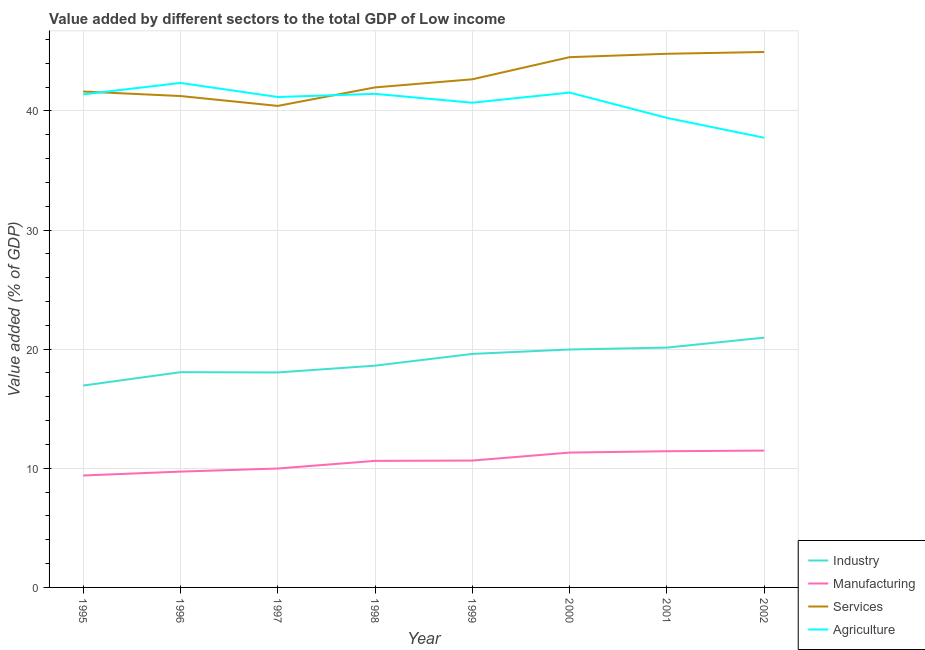Does the line corresponding to value added by services sector intersect with the line corresponding to value added by agricultural sector?
Provide a succinct answer. Yes. What is the value added by industrial sector in 2001?
Give a very brief answer. 20.13. Across all years, what is the maximum value added by agricultural sector?
Make the answer very short. 42.35. Across all years, what is the minimum value added by agricultural sector?
Ensure brevity in your answer.  37.75. In which year was the value added by industrial sector minimum?
Your answer should be compact. 1995. What is the total value added by industrial sector in the graph?
Ensure brevity in your answer.  152.34. What is the difference between the value added by services sector in 1997 and that in 1998?
Give a very brief answer. -1.55. What is the difference between the value added by industrial sector in 2001 and the value added by manufacturing sector in 1999?
Keep it short and to the point. 9.48. What is the average value added by agricultural sector per year?
Offer a very short reply. 40.71. In the year 2001, what is the difference between the value added by manufacturing sector and value added by services sector?
Ensure brevity in your answer.  -33.36. In how many years, is the value added by industrial sector greater than 34 %?
Your response must be concise. 0. What is the ratio of the value added by services sector in 1995 to that in 1996?
Keep it short and to the point. 1.01. What is the difference between the highest and the second highest value added by services sector?
Your answer should be very brief. 0.15. What is the difference between the highest and the lowest value added by manufacturing sector?
Ensure brevity in your answer.  2.09. In how many years, is the value added by services sector greater than the average value added by services sector taken over all years?
Your response must be concise. 3. Is the sum of the value added by agricultural sector in 1999 and 2000 greater than the maximum value added by industrial sector across all years?
Provide a succinct answer. Yes. Is it the case that in every year, the sum of the value added by industrial sector and value added by manufacturing sector is greater than the sum of value added by agricultural sector and value added by services sector?
Your answer should be very brief. No. Is it the case that in every year, the sum of the value added by industrial sector and value added by manufacturing sector is greater than the value added by services sector?
Keep it short and to the point. No. Is the value added by manufacturing sector strictly greater than the value added by services sector over the years?
Give a very brief answer. No. How many lines are there?
Your response must be concise. 4. Does the graph contain any zero values?
Your answer should be compact. No. Where does the legend appear in the graph?
Your response must be concise. Bottom right. How many legend labels are there?
Your answer should be compact. 4. How are the legend labels stacked?
Offer a terse response. Vertical. What is the title of the graph?
Offer a terse response. Value added by different sectors to the total GDP of Low income. Does "Tertiary education" appear as one of the legend labels in the graph?
Offer a terse response. No. What is the label or title of the X-axis?
Your answer should be compact. Year. What is the label or title of the Y-axis?
Provide a short and direct response. Value added (% of GDP). What is the Value added (% of GDP) in Industry in 1995?
Your response must be concise. 16.95. What is the Value added (% of GDP) in Manufacturing in 1995?
Provide a succinct answer. 9.4. What is the Value added (% of GDP) in Services in 1995?
Provide a succinct answer. 41.62. What is the Value added (% of GDP) of Agriculture in 1995?
Make the answer very short. 41.39. What is the Value added (% of GDP) of Industry in 1996?
Offer a terse response. 18.07. What is the Value added (% of GDP) in Manufacturing in 1996?
Your answer should be compact. 9.72. What is the Value added (% of GDP) of Services in 1996?
Offer a very short reply. 41.25. What is the Value added (% of GDP) of Agriculture in 1996?
Your answer should be very brief. 42.35. What is the Value added (% of GDP) of Industry in 1997?
Offer a terse response. 18.04. What is the Value added (% of GDP) of Manufacturing in 1997?
Your answer should be very brief. 9.98. What is the Value added (% of GDP) in Services in 1997?
Your answer should be compact. 40.42. What is the Value added (% of GDP) of Agriculture in 1997?
Offer a very short reply. 41.16. What is the Value added (% of GDP) in Industry in 1998?
Offer a very short reply. 18.61. What is the Value added (% of GDP) in Manufacturing in 1998?
Make the answer very short. 10.62. What is the Value added (% of GDP) of Services in 1998?
Your response must be concise. 41.97. What is the Value added (% of GDP) of Agriculture in 1998?
Your answer should be very brief. 41.43. What is the Value added (% of GDP) of Industry in 1999?
Provide a short and direct response. 19.6. What is the Value added (% of GDP) of Manufacturing in 1999?
Make the answer very short. 10.65. What is the Value added (% of GDP) of Services in 1999?
Ensure brevity in your answer.  42.65. What is the Value added (% of GDP) of Agriculture in 1999?
Ensure brevity in your answer.  40.69. What is the Value added (% of GDP) in Industry in 2000?
Offer a terse response. 19.97. What is the Value added (% of GDP) in Manufacturing in 2000?
Offer a terse response. 11.32. What is the Value added (% of GDP) of Services in 2000?
Give a very brief answer. 44.51. What is the Value added (% of GDP) in Agriculture in 2000?
Offer a terse response. 41.54. What is the Value added (% of GDP) of Industry in 2001?
Your answer should be very brief. 20.13. What is the Value added (% of GDP) in Manufacturing in 2001?
Make the answer very short. 11.43. What is the Value added (% of GDP) in Services in 2001?
Provide a short and direct response. 44.79. What is the Value added (% of GDP) in Agriculture in 2001?
Your answer should be very brief. 39.41. What is the Value added (% of GDP) in Industry in 2002?
Your response must be concise. 20.97. What is the Value added (% of GDP) of Manufacturing in 2002?
Give a very brief answer. 11.49. What is the Value added (% of GDP) of Services in 2002?
Make the answer very short. 44.94. What is the Value added (% of GDP) in Agriculture in 2002?
Give a very brief answer. 37.75. Across all years, what is the maximum Value added (% of GDP) of Industry?
Ensure brevity in your answer.  20.97. Across all years, what is the maximum Value added (% of GDP) in Manufacturing?
Offer a terse response. 11.49. Across all years, what is the maximum Value added (% of GDP) of Services?
Your answer should be compact. 44.94. Across all years, what is the maximum Value added (% of GDP) of Agriculture?
Provide a short and direct response. 42.35. Across all years, what is the minimum Value added (% of GDP) in Industry?
Provide a short and direct response. 16.95. Across all years, what is the minimum Value added (% of GDP) in Manufacturing?
Ensure brevity in your answer.  9.4. Across all years, what is the minimum Value added (% of GDP) of Services?
Make the answer very short. 40.42. Across all years, what is the minimum Value added (% of GDP) in Agriculture?
Provide a short and direct response. 37.75. What is the total Value added (% of GDP) of Industry in the graph?
Offer a very short reply. 152.34. What is the total Value added (% of GDP) of Manufacturing in the graph?
Ensure brevity in your answer.  84.61. What is the total Value added (% of GDP) of Services in the graph?
Offer a very short reply. 342.16. What is the total Value added (% of GDP) of Agriculture in the graph?
Provide a succinct answer. 325.71. What is the difference between the Value added (% of GDP) in Industry in 1995 and that in 1996?
Offer a terse response. -1.12. What is the difference between the Value added (% of GDP) of Manufacturing in 1995 and that in 1996?
Your answer should be very brief. -0.33. What is the difference between the Value added (% of GDP) in Services in 1995 and that in 1996?
Give a very brief answer. 0.38. What is the difference between the Value added (% of GDP) in Agriculture in 1995 and that in 1996?
Offer a very short reply. -0.96. What is the difference between the Value added (% of GDP) in Industry in 1995 and that in 1997?
Keep it short and to the point. -1.1. What is the difference between the Value added (% of GDP) in Manufacturing in 1995 and that in 1997?
Offer a terse response. -0.59. What is the difference between the Value added (% of GDP) in Services in 1995 and that in 1997?
Offer a very short reply. 1.21. What is the difference between the Value added (% of GDP) in Agriculture in 1995 and that in 1997?
Offer a terse response. 0.22. What is the difference between the Value added (% of GDP) of Industry in 1995 and that in 1998?
Your answer should be very brief. -1.67. What is the difference between the Value added (% of GDP) in Manufacturing in 1995 and that in 1998?
Provide a succinct answer. -1.23. What is the difference between the Value added (% of GDP) of Services in 1995 and that in 1998?
Your response must be concise. -0.35. What is the difference between the Value added (% of GDP) of Agriculture in 1995 and that in 1998?
Give a very brief answer. -0.05. What is the difference between the Value added (% of GDP) of Industry in 1995 and that in 1999?
Your answer should be very brief. -2.66. What is the difference between the Value added (% of GDP) in Manufacturing in 1995 and that in 1999?
Offer a very short reply. -1.25. What is the difference between the Value added (% of GDP) of Services in 1995 and that in 1999?
Your answer should be compact. -1.03. What is the difference between the Value added (% of GDP) in Industry in 1995 and that in 2000?
Offer a very short reply. -3.03. What is the difference between the Value added (% of GDP) in Manufacturing in 1995 and that in 2000?
Offer a terse response. -1.92. What is the difference between the Value added (% of GDP) in Services in 1995 and that in 2000?
Provide a short and direct response. -2.88. What is the difference between the Value added (% of GDP) in Agriculture in 1995 and that in 2000?
Offer a very short reply. -0.15. What is the difference between the Value added (% of GDP) of Industry in 1995 and that in 2001?
Your answer should be compact. -3.19. What is the difference between the Value added (% of GDP) in Manufacturing in 1995 and that in 2001?
Ensure brevity in your answer.  -2.04. What is the difference between the Value added (% of GDP) in Services in 1995 and that in 2001?
Ensure brevity in your answer.  -3.17. What is the difference between the Value added (% of GDP) of Agriculture in 1995 and that in 2001?
Offer a terse response. 1.97. What is the difference between the Value added (% of GDP) in Industry in 1995 and that in 2002?
Your answer should be very brief. -4.02. What is the difference between the Value added (% of GDP) of Manufacturing in 1995 and that in 2002?
Provide a succinct answer. -2.09. What is the difference between the Value added (% of GDP) in Services in 1995 and that in 2002?
Ensure brevity in your answer.  -3.32. What is the difference between the Value added (% of GDP) in Agriculture in 1995 and that in 2002?
Provide a succinct answer. 3.64. What is the difference between the Value added (% of GDP) of Industry in 1996 and that in 1997?
Offer a very short reply. 0.02. What is the difference between the Value added (% of GDP) of Manufacturing in 1996 and that in 1997?
Ensure brevity in your answer.  -0.26. What is the difference between the Value added (% of GDP) of Services in 1996 and that in 1997?
Your answer should be compact. 0.83. What is the difference between the Value added (% of GDP) of Agriculture in 1996 and that in 1997?
Offer a terse response. 1.18. What is the difference between the Value added (% of GDP) in Industry in 1996 and that in 1998?
Ensure brevity in your answer.  -0.55. What is the difference between the Value added (% of GDP) of Manufacturing in 1996 and that in 1998?
Make the answer very short. -0.9. What is the difference between the Value added (% of GDP) in Services in 1996 and that in 1998?
Offer a very short reply. -0.72. What is the difference between the Value added (% of GDP) of Agriculture in 1996 and that in 1998?
Offer a terse response. 0.92. What is the difference between the Value added (% of GDP) of Industry in 1996 and that in 1999?
Give a very brief answer. -1.53. What is the difference between the Value added (% of GDP) in Manufacturing in 1996 and that in 1999?
Keep it short and to the point. -0.93. What is the difference between the Value added (% of GDP) of Services in 1996 and that in 1999?
Your response must be concise. -1.41. What is the difference between the Value added (% of GDP) of Agriculture in 1996 and that in 1999?
Ensure brevity in your answer.  1.66. What is the difference between the Value added (% of GDP) of Industry in 1996 and that in 2000?
Your answer should be compact. -1.9. What is the difference between the Value added (% of GDP) in Manufacturing in 1996 and that in 2000?
Give a very brief answer. -1.6. What is the difference between the Value added (% of GDP) of Services in 1996 and that in 2000?
Offer a very short reply. -3.26. What is the difference between the Value added (% of GDP) in Agriculture in 1996 and that in 2000?
Keep it short and to the point. 0.81. What is the difference between the Value added (% of GDP) in Industry in 1996 and that in 2001?
Provide a succinct answer. -2.06. What is the difference between the Value added (% of GDP) in Manufacturing in 1996 and that in 2001?
Provide a short and direct response. -1.71. What is the difference between the Value added (% of GDP) in Services in 1996 and that in 2001?
Give a very brief answer. -3.55. What is the difference between the Value added (% of GDP) in Agriculture in 1996 and that in 2001?
Keep it short and to the point. 2.93. What is the difference between the Value added (% of GDP) of Industry in 1996 and that in 2002?
Your answer should be compact. -2.9. What is the difference between the Value added (% of GDP) of Manufacturing in 1996 and that in 2002?
Your response must be concise. -1.76. What is the difference between the Value added (% of GDP) in Services in 1996 and that in 2002?
Provide a succinct answer. -3.7. What is the difference between the Value added (% of GDP) in Agriculture in 1996 and that in 2002?
Provide a short and direct response. 4.6. What is the difference between the Value added (% of GDP) in Industry in 1997 and that in 1998?
Give a very brief answer. -0.57. What is the difference between the Value added (% of GDP) of Manufacturing in 1997 and that in 1998?
Keep it short and to the point. -0.64. What is the difference between the Value added (% of GDP) in Services in 1997 and that in 1998?
Your response must be concise. -1.55. What is the difference between the Value added (% of GDP) in Agriculture in 1997 and that in 1998?
Your answer should be very brief. -0.27. What is the difference between the Value added (% of GDP) in Industry in 1997 and that in 1999?
Your response must be concise. -1.56. What is the difference between the Value added (% of GDP) in Manufacturing in 1997 and that in 1999?
Ensure brevity in your answer.  -0.67. What is the difference between the Value added (% of GDP) of Services in 1997 and that in 1999?
Your answer should be very brief. -2.23. What is the difference between the Value added (% of GDP) in Agriculture in 1997 and that in 1999?
Your answer should be very brief. 0.48. What is the difference between the Value added (% of GDP) of Industry in 1997 and that in 2000?
Offer a very short reply. -1.93. What is the difference between the Value added (% of GDP) of Manufacturing in 1997 and that in 2000?
Offer a terse response. -1.34. What is the difference between the Value added (% of GDP) in Services in 1997 and that in 2000?
Offer a very short reply. -4.09. What is the difference between the Value added (% of GDP) of Agriculture in 1997 and that in 2000?
Give a very brief answer. -0.37. What is the difference between the Value added (% of GDP) in Industry in 1997 and that in 2001?
Give a very brief answer. -2.09. What is the difference between the Value added (% of GDP) of Manufacturing in 1997 and that in 2001?
Your response must be concise. -1.45. What is the difference between the Value added (% of GDP) in Services in 1997 and that in 2001?
Your answer should be very brief. -4.38. What is the difference between the Value added (% of GDP) of Agriculture in 1997 and that in 2001?
Offer a terse response. 1.75. What is the difference between the Value added (% of GDP) in Industry in 1997 and that in 2002?
Provide a succinct answer. -2.92. What is the difference between the Value added (% of GDP) of Manufacturing in 1997 and that in 2002?
Offer a very short reply. -1.51. What is the difference between the Value added (% of GDP) in Services in 1997 and that in 2002?
Make the answer very short. -4.53. What is the difference between the Value added (% of GDP) of Agriculture in 1997 and that in 2002?
Ensure brevity in your answer.  3.42. What is the difference between the Value added (% of GDP) in Industry in 1998 and that in 1999?
Keep it short and to the point. -0.99. What is the difference between the Value added (% of GDP) in Manufacturing in 1998 and that in 1999?
Offer a terse response. -0.02. What is the difference between the Value added (% of GDP) in Services in 1998 and that in 1999?
Give a very brief answer. -0.68. What is the difference between the Value added (% of GDP) of Agriculture in 1998 and that in 1999?
Make the answer very short. 0.75. What is the difference between the Value added (% of GDP) of Industry in 1998 and that in 2000?
Give a very brief answer. -1.36. What is the difference between the Value added (% of GDP) of Manufacturing in 1998 and that in 2000?
Ensure brevity in your answer.  -0.7. What is the difference between the Value added (% of GDP) of Services in 1998 and that in 2000?
Offer a very short reply. -2.54. What is the difference between the Value added (% of GDP) of Agriculture in 1998 and that in 2000?
Give a very brief answer. -0.11. What is the difference between the Value added (% of GDP) in Industry in 1998 and that in 2001?
Give a very brief answer. -1.52. What is the difference between the Value added (% of GDP) in Manufacturing in 1998 and that in 2001?
Keep it short and to the point. -0.81. What is the difference between the Value added (% of GDP) in Services in 1998 and that in 2001?
Keep it short and to the point. -2.82. What is the difference between the Value added (% of GDP) of Agriculture in 1998 and that in 2001?
Your answer should be compact. 2.02. What is the difference between the Value added (% of GDP) in Industry in 1998 and that in 2002?
Offer a terse response. -2.35. What is the difference between the Value added (% of GDP) in Manufacturing in 1998 and that in 2002?
Your response must be concise. -0.86. What is the difference between the Value added (% of GDP) of Services in 1998 and that in 2002?
Ensure brevity in your answer.  -2.97. What is the difference between the Value added (% of GDP) in Agriculture in 1998 and that in 2002?
Your response must be concise. 3.68. What is the difference between the Value added (% of GDP) of Industry in 1999 and that in 2000?
Keep it short and to the point. -0.37. What is the difference between the Value added (% of GDP) in Manufacturing in 1999 and that in 2000?
Offer a very short reply. -0.67. What is the difference between the Value added (% of GDP) in Services in 1999 and that in 2000?
Ensure brevity in your answer.  -1.86. What is the difference between the Value added (% of GDP) of Agriculture in 1999 and that in 2000?
Your answer should be compact. -0.85. What is the difference between the Value added (% of GDP) of Industry in 1999 and that in 2001?
Provide a short and direct response. -0.53. What is the difference between the Value added (% of GDP) in Manufacturing in 1999 and that in 2001?
Give a very brief answer. -0.78. What is the difference between the Value added (% of GDP) of Services in 1999 and that in 2001?
Provide a short and direct response. -2.14. What is the difference between the Value added (% of GDP) of Agriculture in 1999 and that in 2001?
Keep it short and to the point. 1.27. What is the difference between the Value added (% of GDP) in Industry in 1999 and that in 2002?
Your answer should be very brief. -1.36. What is the difference between the Value added (% of GDP) in Manufacturing in 1999 and that in 2002?
Offer a very short reply. -0.84. What is the difference between the Value added (% of GDP) of Services in 1999 and that in 2002?
Give a very brief answer. -2.29. What is the difference between the Value added (% of GDP) of Agriculture in 1999 and that in 2002?
Your answer should be very brief. 2.94. What is the difference between the Value added (% of GDP) of Industry in 2000 and that in 2001?
Offer a very short reply. -0.16. What is the difference between the Value added (% of GDP) in Manufacturing in 2000 and that in 2001?
Provide a short and direct response. -0.11. What is the difference between the Value added (% of GDP) of Services in 2000 and that in 2001?
Your answer should be compact. -0.28. What is the difference between the Value added (% of GDP) of Agriculture in 2000 and that in 2001?
Your answer should be compact. 2.12. What is the difference between the Value added (% of GDP) in Industry in 2000 and that in 2002?
Provide a short and direct response. -0.99. What is the difference between the Value added (% of GDP) in Services in 2000 and that in 2002?
Ensure brevity in your answer.  -0.43. What is the difference between the Value added (% of GDP) in Agriculture in 2000 and that in 2002?
Make the answer very short. 3.79. What is the difference between the Value added (% of GDP) of Industry in 2001 and that in 2002?
Your response must be concise. -0.83. What is the difference between the Value added (% of GDP) in Manufacturing in 2001 and that in 2002?
Make the answer very short. -0.05. What is the difference between the Value added (% of GDP) of Services in 2001 and that in 2002?
Your answer should be very brief. -0.15. What is the difference between the Value added (% of GDP) in Agriculture in 2001 and that in 2002?
Provide a short and direct response. 1.67. What is the difference between the Value added (% of GDP) in Industry in 1995 and the Value added (% of GDP) in Manufacturing in 1996?
Ensure brevity in your answer.  7.22. What is the difference between the Value added (% of GDP) in Industry in 1995 and the Value added (% of GDP) in Services in 1996?
Your answer should be very brief. -24.3. What is the difference between the Value added (% of GDP) of Industry in 1995 and the Value added (% of GDP) of Agriculture in 1996?
Offer a very short reply. -25.4. What is the difference between the Value added (% of GDP) of Manufacturing in 1995 and the Value added (% of GDP) of Services in 1996?
Your answer should be compact. -31.85. What is the difference between the Value added (% of GDP) in Manufacturing in 1995 and the Value added (% of GDP) in Agriculture in 1996?
Keep it short and to the point. -32.95. What is the difference between the Value added (% of GDP) in Services in 1995 and the Value added (% of GDP) in Agriculture in 1996?
Offer a terse response. -0.72. What is the difference between the Value added (% of GDP) in Industry in 1995 and the Value added (% of GDP) in Manufacturing in 1997?
Make the answer very short. 6.96. What is the difference between the Value added (% of GDP) in Industry in 1995 and the Value added (% of GDP) in Services in 1997?
Provide a succinct answer. -23.47. What is the difference between the Value added (% of GDP) of Industry in 1995 and the Value added (% of GDP) of Agriculture in 1997?
Ensure brevity in your answer.  -24.22. What is the difference between the Value added (% of GDP) of Manufacturing in 1995 and the Value added (% of GDP) of Services in 1997?
Provide a short and direct response. -31.02. What is the difference between the Value added (% of GDP) of Manufacturing in 1995 and the Value added (% of GDP) of Agriculture in 1997?
Offer a terse response. -31.77. What is the difference between the Value added (% of GDP) in Services in 1995 and the Value added (% of GDP) in Agriculture in 1997?
Offer a terse response. 0.46. What is the difference between the Value added (% of GDP) of Industry in 1995 and the Value added (% of GDP) of Manufacturing in 1998?
Your answer should be compact. 6.32. What is the difference between the Value added (% of GDP) in Industry in 1995 and the Value added (% of GDP) in Services in 1998?
Offer a terse response. -25.03. What is the difference between the Value added (% of GDP) of Industry in 1995 and the Value added (% of GDP) of Agriculture in 1998?
Offer a very short reply. -24.49. What is the difference between the Value added (% of GDP) in Manufacturing in 1995 and the Value added (% of GDP) in Services in 1998?
Keep it short and to the point. -32.58. What is the difference between the Value added (% of GDP) of Manufacturing in 1995 and the Value added (% of GDP) of Agriculture in 1998?
Make the answer very short. -32.04. What is the difference between the Value added (% of GDP) in Services in 1995 and the Value added (% of GDP) in Agriculture in 1998?
Your response must be concise. 0.19. What is the difference between the Value added (% of GDP) of Industry in 1995 and the Value added (% of GDP) of Manufacturing in 1999?
Your response must be concise. 6.3. What is the difference between the Value added (% of GDP) of Industry in 1995 and the Value added (% of GDP) of Services in 1999?
Give a very brief answer. -25.71. What is the difference between the Value added (% of GDP) of Industry in 1995 and the Value added (% of GDP) of Agriculture in 1999?
Your response must be concise. -23.74. What is the difference between the Value added (% of GDP) of Manufacturing in 1995 and the Value added (% of GDP) of Services in 1999?
Your response must be concise. -33.26. What is the difference between the Value added (% of GDP) of Manufacturing in 1995 and the Value added (% of GDP) of Agriculture in 1999?
Offer a terse response. -31.29. What is the difference between the Value added (% of GDP) in Services in 1995 and the Value added (% of GDP) in Agriculture in 1999?
Give a very brief answer. 0.94. What is the difference between the Value added (% of GDP) of Industry in 1995 and the Value added (% of GDP) of Manufacturing in 2000?
Provide a succinct answer. 5.63. What is the difference between the Value added (% of GDP) in Industry in 1995 and the Value added (% of GDP) in Services in 2000?
Keep it short and to the point. -27.56. What is the difference between the Value added (% of GDP) of Industry in 1995 and the Value added (% of GDP) of Agriculture in 2000?
Offer a terse response. -24.59. What is the difference between the Value added (% of GDP) in Manufacturing in 1995 and the Value added (% of GDP) in Services in 2000?
Your answer should be very brief. -35.11. What is the difference between the Value added (% of GDP) of Manufacturing in 1995 and the Value added (% of GDP) of Agriculture in 2000?
Provide a succinct answer. -32.14. What is the difference between the Value added (% of GDP) of Services in 1995 and the Value added (% of GDP) of Agriculture in 2000?
Give a very brief answer. 0.09. What is the difference between the Value added (% of GDP) in Industry in 1995 and the Value added (% of GDP) in Manufacturing in 2001?
Ensure brevity in your answer.  5.51. What is the difference between the Value added (% of GDP) in Industry in 1995 and the Value added (% of GDP) in Services in 2001?
Your response must be concise. -27.85. What is the difference between the Value added (% of GDP) of Industry in 1995 and the Value added (% of GDP) of Agriculture in 2001?
Ensure brevity in your answer.  -22.47. What is the difference between the Value added (% of GDP) in Manufacturing in 1995 and the Value added (% of GDP) in Services in 2001?
Provide a succinct answer. -35.4. What is the difference between the Value added (% of GDP) of Manufacturing in 1995 and the Value added (% of GDP) of Agriculture in 2001?
Your answer should be very brief. -30.02. What is the difference between the Value added (% of GDP) of Services in 1995 and the Value added (% of GDP) of Agriculture in 2001?
Provide a short and direct response. 2.21. What is the difference between the Value added (% of GDP) in Industry in 1995 and the Value added (% of GDP) in Manufacturing in 2002?
Give a very brief answer. 5.46. What is the difference between the Value added (% of GDP) in Industry in 1995 and the Value added (% of GDP) in Services in 2002?
Keep it short and to the point. -28. What is the difference between the Value added (% of GDP) in Industry in 1995 and the Value added (% of GDP) in Agriculture in 2002?
Offer a very short reply. -20.8. What is the difference between the Value added (% of GDP) of Manufacturing in 1995 and the Value added (% of GDP) of Services in 2002?
Ensure brevity in your answer.  -35.55. What is the difference between the Value added (% of GDP) in Manufacturing in 1995 and the Value added (% of GDP) in Agriculture in 2002?
Give a very brief answer. -28.35. What is the difference between the Value added (% of GDP) in Services in 1995 and the Value added (% of GDP) in Agriculture in 2002?
Provide a short and direct response. 3.88. What is the difference between the Value added (% of GDP) in Industry in 1996 and the Value added (% of GDP) in Manufacturing in 1997?
Make the answer very short. 8.09. What is the difference between the Value added (% of GDP) in Industry in 1996 and the Value added (% of GDP) in Services in 1997?
Provide a short and direct response. -22.35. What is the difference between the Value added (% of GDP) in Industry in 1996 and the Value added (% of GDP) in Agriculture in 1997?
Offer a terse response. -23.1. What is the difference between the Value added (% of GDP) of Manufacturing in 1996 and the Value added (% of GDP) of Services in 1997?
Offer a very short reply. -30.7. What is the difference between the Value added (% of GDP) of Manufacturing in 1996 and the Value added (% of GDP) of Agriculture in 1997?
Offer a terse response. -31.44. What is the difference between the Value added (% of GDP) of Services in 1996 and the Value added (% of GDP) of Agriculture in 1997?
Your answer should be very brief. 0.08. What is the difference between the Value added (% of GDP) of Industry in 1996 and the Value added (% of GDP) of Manufacturing in 1998?
Offer a terse response. 7.44. What is the difference between the Value added (% of GDP) in Industry in 1996 and the Value added (% of GDP) in Services in 1998?
Your answer should be compact. -23.9. What is the difference between the Value added (% of GDP) in Industry in 1996 and the Value added (% of GDP) in Agriculture in 1998?
Provide a short and direct response. -23.36. What is the difference between the Value added (% of GDP) of Manufacturing in 1996 and the Value added (% of GDP) of Services in 1998?
Your answer should be very brief. -32.25. What is the difference between the Value added (% of GDP) in Manufacturing in 1996 and the Value added (% of GDP) in Agriculture in 1998?
Give a very brief answer. -31.71. What is the difference between the Value added (% of GDP) in Services in 1996 and the Value added (% of GDP) in Agriculture in 1998?
Your response must be concise. -0.18. What is the difference between the Value added (% of GDP) of Industry in 1996 and the Value added (% of GDP) of Manufacturing in 1999?
Offer a very short reply. 7.42. What is the difference between the Value added (% of GDP) in Industry in 1996 and the Value added (% of GDP) in Services in 1999?
Offer a terse response. -24.58. What is the difference between the Value added (% of GDP) in Industry in 1996 and the Value added (% of GDP) in Agriculture in 1999?
Keep it short and to the point. -22.62. What is the difference between the Value added (% of GDP) in Manufacturing in 1996 and the Value added (% of GDP) in Services in 1999?
Ensure brevity in your answer.  -32.93. What is the difference between the Value added (% of GDP) in Manufacturing in 1996 and the Value added (% of GDP) in Agriculture in 1999?
Your answer should be very brief. -30.96. What is the difference between the Value added (% of GDP) in Services in 1996 and the Value added (% of GDP) in Agriculture in 1999?
Your response must be concise. 0.56. What is the difference between the Value added (% of GDP) of Industry in 1996 and the Value added (% of GDP) of Manufacturing in 2000?
Your answer should be compact. 6.75. What is the difference between the Value added (% of GDP) in Industry in 1996 and the Value added (% of GDP) in Services in 2000?
Provide a short and direct response. -26.44. What is the difference between the Value added (% of GDP) of Industry in 1996 and the Value added (% of GDP) of Agriculture in 2000?
Provide a short and direct response. -23.47. What is the difference between the Value added (% of GDP) in Manufacturing in 1996 and the Value added (% of GDP) in Services in 2000?
Keep it short and to the point. -34.79. What is the difference between the Value added (% of GDP) in Manufacturing in 1996 and the Value added (% of GDP) in Agriculture in 2000?
Keep it short and to the point. -31.82. What is the difference between the Value added (% of GDP) in Services in 1996 and the Value added (% of GDP) in Agriculture in 2000?
Your answer should be very brief. -0.29. What is the difference between the Value added (% of GDP) in Industry in 1996 and the Value added (% of GDP) in Manufacturing in 2001?
Your answer should be very brief. 6.64. What is the difference between the Value added (% of GDP) of Industry in 1996 and the Value added (% of GDP) of Services in 2001?
Offer a very short reply. -26.73. What is the difference between the Value added (% of GDP) in Industry in 1996 and the Value added (% of GDP) in Agriculture in 2001?
Your answer should be very brief. -21.35. What is the difference between the Value added (% of GDP) in Manufacturing in 1996 and the Value added (% of GDP) in Services in 2001?
Provide a short and direct response. -35.07. What is the difference between the Value added (% of GDP) in Manufacturing in 1996 and the Value added (% of GDP) in Agriculture in 2001?
Provide a succinct answer. -29.69. What is the difference between the Value added (% of GDP) of Services in 1996 and the Value added (% of GDP) of Agriculture in 2001?
Your answer should be compact. 1.83. What is the difference between the Value added (% of GDP) of Industry in 1996 and the Value added (% of GDP) of Manufacturing in 2002?
Offer a terse response. 6.58. What is the difference between the Value added (% of GDP) of Industry in 1996 and the Value added (% of GDP) of Services in 2002?
Make the answer very short. -26.87. What is the difference between the Value added (% of GDP) in Industry in 1996 and the Value added (% of GDP) in Agriculture in 2002?
Ensure brevity in your answer.  -19.68. What is the difference between the Value added (% of GDP) of Manufacturing in 1996 and the Value added (% of GDP) of Services in 2002?
Ensure brevity in your answer.  -35.22. What is the difference between the Value added (% of GDP) of Manufacturing in 1996 and the Value added (% of GDP) of Agriculture in 2002?
Offer a very short reply. -28.03. What is the difference between the Value added (% of GDP) in Services in 1996 and the Value added (% of GDP) in Agriculture in 2002?
Provide a succinct answer. 3.5. What is the difference between the Value added (% of GDP) in Industry in 1997 and the Value added (% of GDP) in Manufacturing in 1998?
Provide a succinct answer. 7.42. What is the difference between the Value added (% of GDP) of Industry in 1997 and the Value added (% of GDP) of Services in 1998?
Ensure brevity in your answer.  -23.93. What is the difference between the Value added (% of GDP) in Industry in 1997 and the Value added (% of GDP) in Agriculture in 1998?
Your answer should be very brief. -23.39. What is the difference between the Value added (% of GDP) of Manufacturing in 1997 and the Value added (% of GDP) of Services in 1998?
Keep it short and to the point. -31.99. What is the difference between the Value added (% of GDP) of Manufacturing in 1997 and the Value added (% of GDP) of Agriculture in 1998?
Offer a very short reply. -31.45. What is the difference between the Value added (% of GDP) of Services in 1997 and the Value added (% of GDP) of Agriculture in 1998?
Offer a very short reply. -1.01. What is the difference between the Value added (% of GDP) in Industry in 1997 and the Value added (% of GDP) in Manufacturing in 1999?
Offer a very short reply. 7.4. What is the difference between the Value added (% of GDP) of Industry in 1997 and the Value added (% of GDP) of Services in 1999?
Offer a very short reply. -24.61. What is the difference between the Value added (% of GDP) in Industry in 1997 and the Value added (% of GDP) in Agriculture in 1999?
Provide a succinct answer. -22.64. What is the difference between the Value added (% of GDP) of Manufacturing in 1997 and the Value added (% of GDP) of Services in 1999?
Keep it short and to the point. -32.67. What is the difference between the Value added (% of GDP) of Manufacturing in 1997 and the Value added (% of GDP) of Agriculture in 1999?
Make the answer very short. -30.7. What is the difference between the Value added (% of GDP) of Services in 1997 and the Value added (% of GDP) of Agriculture in 1999?
Provide a succinct answer. -0.27. What is the difference between the Value added (% of GDP) in Industry in 1997 and the Value added (% of GDP) in Manufacturing in 2000?
Offer a very short reply. 6.72. What is the difference between the Value added (% of GDP) of Industry in 1997 and the Value added (% of GDP) of Services in 2000?
Make the answer very short. -26.46. What is the difference between the Value added (% of GDP) of Industry in 1997 and the Value added (% of GDP) of Agriculture in 2000?
Offer a very short reply. -23.49. What is the difference between the Value added (% of GDP) in Manufacturing in 1997 and the Value added (% of GDP) in Services in 2000?
Keep it short and to the point. -34.53. What is the difference between the Value added (% of GDP) of Manufacturing in 1997 and the Value added (% of GDP) of Agriculture in 2000?
Ensure brevity in your answer.  -31.56. What is the difference between the Value added (% of GDP) of Services in 1997 and the Value added (% of GDP) of Agriculture in 2000?
Provide a short and direct response. -1.12. What is the difference between the Value added (% of GDP) of Industry in 1997 and the Value added (% of GDP) of Manufacturing in 2001?
Provide a succinct answer. 6.61. What is the difference between the Value added (% of GDP) of Industry in 1997 and the Value added (% of GDP) of Services in 2001?
Provide a succinct answer. -26.75. What is the difference between the Value added (% of GDP) of Industry in 1997 and the Value added (% of GDP) of Agriculture in 2001?
Give a very brief answer. -21.37. What is the difference between the Value added (% of GDP) in Manufacturing in 1997 and the Value added (% of GDP) in Services in 2001?
Provide a succinct answer. -34.81. What is the difference between the Value added (% of GDP) of Manufacturing in 1997 and the Value added (% of GDP) of Agriculture in 2001?
Ensure brevity in your answer.  -29.43. What is the difference between the Value added (% of GDP) of Industry in 1997 and the Value added (% of GDP) of Manufacturing in 2002?
Offer a terse response. 6.56. What is the difference between the Value added (% of GDP) of Industry in 1997 and the Value added (% of GDP) of Services in 2002?
Your answer should be compact. -26.9. What is the difference between the Value added (% of GDP) in Industry in 1997 and the Value added (% of GDP) in Agriculture in 2002?
Give a very brief answer. -19.7. What is the difference between the Value added (% of GDP) of Manufacturing in 1997 and the Value added (% of GDP) of Services in 2002?
Offer a terse response. -34.96. What is the difference between the Value added (% of GDP) of Manufacturing in 1997 and the Value added (% of GDP) of Agriculture in 2002?
Offer a terse response. -27.77. What is the difference between the Value added (% of GDP) in Services in 1997 and the Value added (% of GDP) in Agriculture in 2002?
Your response must be concise. 2.67. What is the difference between the Value added (% of GDP) in Industry in 1998 and the Value added (% of GDP) in Manufacturing in 1999?
Offer a very short reply. 7.97. What is the difference between the Value added (% of GDP) in Industry in 1998 and the Value added (% of GDP) in Services in 1999?
Keep it short and to the point. -24.04. What is the difference between the Value added (% of GDP) in Industry in 1998 and the Value added (% of GDP) in Agriculture in 1999?
Offer a very short reply. -22.07. What is the difference between the Value added (% of GDP) of Manufacturing in 1998 and the Value added (% of GDP) of Services in 1999?
Provide a succinct answer. -32.03. What is the difference between the Value added (% of GDP) of Manufacturing in 1998 and the Value added (% of GDP) of Agriculture in 1999?
Your response must be concise. -30.06. What is the difference between the Value added (% of GDP) in Services in 1998 and the Value added (% of GDP) in Agriculture in 1999?
Offer a terse response. 1.29. What is the difference between the Value added (% of GDP) of Industry in 1998 and the Value added (% of GDP) of Manufacturing in 2000?
Provide a succinct answer. 7.29. What is the difference between the Value added (% of GDP) of Industry in 1998 and the Value added (% of GDP) of Services in 2000?
Give a very brief answer. -25.89. What is the difference between the Value added (% of GDP) of Industry in 1998 and the Value added (% of GDP) of Agriculture in 2000?
Your response must be concise. -22.92. What is the difference between the Value added (% of GDP) of Manufacturing in 1998 and the Value added (% of GDP) of Services in 2000?
Your answer should be very brief. -33.89. What is the difference between the Value added (% of GDP) of Manufacturing in 1998 and the Value added (% of GDP) of Agriculture in 2000?
Make the answer very short. -30.91. What is the difference between the Value added (% of GDP) of Services in 1998 and the Value added (% of GDP) of Agriculture in 2000?
Provide a short and direct response. 0.43. What is the difference between the Value added (% of GDP) in Industry in 1998 and the Value added (% of GDP) in Manufacturing in 2001?
Keep it short and to the point. 7.18. What is the difference between the Value added (% of GDP) of Industry in 1998 and the Value added (% of GDP) of Services in 2001?
Give a very brief answer. -26.18. What is the difference between the Value added (% of GDP) of Industry in 1998 and the Value added (% of GDP) of Agriculture in 2001?
Your answer should be compact. -20.8. What is the difference between the Value added (% of GDP) in Manufacturing in 1998 and the Value added (% of GDP) in Services in 2001?
Offer a terse response. -34.17. What is the difference between the Value added (% of GDP) of Manufacturing in 1998 and the Value added (% of GDP) of Agriculture in 2001?
Offer a very short reply. -28.79. What is the difference between the Value added (% of GDP) in Services in 1998 and the Value added (% of GDP) in Agriculture in 2001?
Provide a short and direct response. 2.56. What is the difference between the Value added (% of GDP) in Industry in 1998 and the Value added (% of GDP) in Manufacturing in 2002?
Offer a very short reply. 7.13. What is the difference between the Value added (% of GDP) of Industry in 1998 and the Value added (% of GDP) of Services in 2002?
Give a very brief answer. -26.33. What is the difference between the Value added (% of GDP) in Industry in 1998 and the Value added (% of GDP) in Agriculture in 2002?
Ensure brevity in your answer.  -19.13. What is the difference between the Value added (% of GDP) of Manufacturing in 1998 and the Value added (% of GDP) of Services in 2002?
Provide a short and direct response. -34.32. What is the difference between the Value added (% of GDP) of Manufacturing in 1998 and the Value added (% of GDP) of Agriculture in 2002?
Provide a short and direct response. -27.12. What is the difference between the Value added (% of GDP) in Services in 1998 and the Value added (% of GDP) in Agriculture in 2002?
Provide a short and direct response. 4.22. What is the difference between the Value added (% of GDP) in Industry in 1999 and the Value added (% of GDP) in Manufacturing in 2000?
Your answer should be compact. 8.28. What is the difference between the Value added (% of GDP) of Industry in 1999 and the Value added (% of GDP) of Services in 2000?
Provide a short and direct response. -24.91. What is the difference between the Value added (% of GDP) of Industry in 1999 and the Value added (% of GDP) of Agriculture in 2000?
Your answer should be compact. -21.94. What is the difference between the Value added (% of GDP) of Manufacturing in 1999 and the Value added (% of GDP) of Services in 2000?
Make the answer very short. -33.86. What is the difference between the Value added (% of GDP) in Manufacturing in 1999 and the Value added (% of GDP) in Agriculture in 2000?
Offer a very short reply. -30.89. What is the difference between the Value added (% of GDP) of Services in 1999 and the Value added (% of GDP) of Agriculture in 2000?
Your answer should be very brief. 1.11. What is the difference between the Value added (% of GDP) in Industry in 1999 and the Value added (% of GDP) in Manufacturing in 2001?
Your response must be concise. 8.17. What is the difference between the Value added (% of GDP) of Industry in 1999 and the Value added (% of GDP) of Services in 2001?
Make the answer very short. -25.19. What is the difference between the Value added (% of GDP) in Industry in 1999 and the Value added (% of GDP) in Agriculture in 2001?
Provide a succinct answer. -19.81. What is the difference between the Value added (% of GDP) of Manufacturing in 1999 and the Value added (% of GDP) of Services in 2001?
Provide a short and direct response. -34.15. What is the difference between the Value added (% of GDP) in Manufacturing in 1999 and the Value added (% of GDP) in Agriculture in 2001?
Offer a terse response. -28.77. What is the difference between the Value added (% of GDP) of Services in 1999 and the Value added (% of GDP) of Agriculture in 2001?
Keep it short and to the point. 3.24. What is the difference between the Value added (% of GDP) of Industry in 1999 and the Value added (% of GDP) of Manufacturing in 2002?
Make the answer very short. 8.11. What is the difference between the Value added (% of GDP) in Industry in 1999 and the Value added (% of GDP) in Services in 2002?
Your answer should be very brief. -25.34. What is the difference between the Value added (% of GDP) of Industry in 1999 and the Value added (% of GDP) of Agriculture in 2002?
Keep it short and to the point. -18.15. What is the difference between the Value added (% of GDP) of Manufacturing in 1999 and the Value added (% of GDP) of Services in 2002?
Your answer should be compact. -34.29. What is the difference between the Value added (% of GDP) of Manufacturing in 1999 and the Value added (% of GDP) of Agriculture in 2002?
Ensure brevity in your answer.  -27.1. What is the difference between the Value added (% of GDP) of Services in 1999 and the Value added (% of GDP) of Agriculture in 2002?
Offer a terse response. 4.91. What is the difference between the Value added (% of GDP) of Industry in 2000 and the Value added (% of GDP) of Manufacturing in 2001?
Offer a very short reply. 8.54. What is the difference between the Value added (% of GDP) of Industry in 2000 and the Value added (% of GDP) of Services in 2001?
Your answer should be compact. -24.82. What is the difference between the Value added (% of GDP) of Industry in 2000 and the Value added (% of GDP) of Agriculture in 2001?
Make the answer very short. -19.44. What is the difference between the Value added (% of GDP) of Manufacturing in 2000 and the Value added (% of GDP) of Services in 2001?
Keep it short and to the point. -33.47. What is the difference between the Value added (% of GDP) in Manufacturing in 2000 and the Value added (% of GDP) in Agriculture in 2001?
Make the answer very short. -28.09. What is the difference between the Value added (% of GDP) in Services in 2000 and the Value added (% of GDP) in Agriculture in 2001?
Offer a terse response. 5.09. What is the difference between the Value added (% of GDP) of Industry in 2000 and the Value added (% of GDP) of Manufacturing in 2002?
Make the answer very short. 8.49. What is the difference between the Value added (% of GDP) of Industry in 2000 and the Value added (% of GDP) of Services in 2002?
Provide a succinct answer. -24.97. What is the difference between the Value added (% of GDP) in Industry in 2000 and the Value added (% of GDP) in Agriculture in 2002?
Offer a terse response. -17.78. What is the difference between the Value added (% of GDP) in Manufacturing in 2000 and the Value added (% of GDP) in Services in 2002?
Offer a very short reply. -33.62. What is the difference between the Value added (% of GDP) in Manufacturing in 2000 and the Value added (% of GDP) in Agriculture in 2002?
Your answer should be very brief. -26.43. What is the difference between the Value added (% of GDP) in Services in 2000 and the Value added (% of GDP) in Agriculture in 2002?
Make the answer very short. 6.76. What is the difference between the Value added (% of GDP) in Industry in 2001 and the Value added (% of GDP) in Manufacturing in 2002?
Make the answer very short. 8.65. What is the difference between the Value added (% of GDP) in Industry in 2001 and the Value added (% of GDP) in Services in 2002?
Offer a terse response. -24.81. What is the difference between the Value added (% of GDP) of Industry in 2001 and the Value added (% of GDP) of Agriculture in 2002?
Ensure brevity in your answer.  -17.62. What is the difference between the Value added (% of GDP) of Manufacturing in 2001 and the Value added (% of GDP) of Services in 2002?
Provide a succinct answer. -33.51. What is the difference between the Value added (% of GDP) of Manufacturing in 2001 and the Value added (% of GDP) of Agriculture in 2002?
Offer a very short reply. -26.31. What is the difference between the Value added (% of GDP) of Services in 2001 and the Value added (% of GDP) of Agriculture in 2002?
Offer a terse response. 7.05. What is the average Value added (% of GDP) of Industry per year?
Make the answer very short. 19.04. What is the average Value added (% of GDP) in Manufacturing per year?
Provide a short and direct response. 10.58. What is the average Value added (% of GDP) in Services per year?
Your response must be concise. 42.77. What is the average Value added (% of GDP) in Agriculture per year?
Ensure brevity in your answer.  40.71. In the year 1995, what is the difference between the Value added (% of GDP) of Industry and Value added (% of GDP) of Manufacturing?
Make the answer very short. 7.55. In the year 1995, what is the difference between the Value added (% of GDP) of Industry and Value added (% of GDP) of Services?
Provide a short and direct response. -24.68. In the year 1995, what is the difference between the Value added (% of GDP) of Industry and Value added (% of GDP) of Agriculture?
Your answer should be compact. -24.44. In the year 1995, what is the difference between the Value added (% of GDP) of Manufacturing and Value added (% of GDP) of Services?
Offer a very short reply. -32.23. In the year 1995, what is the difference between the Value added (% of GDP) of Manufacturing and Value added (% of GDP) of Agriculture?
Provide a short and direct response. -31.99. In the year 1995, what is the difference between the Value added (% of GDP) in Services and Value added (% of GDP) in Agriculture?
Keep it short and to the point. 0.24. In the year 1996, what is the difference between the Value added (% of GDP) in Industry and Value added (% of GDP) in Manufacturing?
Your answer should be very brief. 8.35. In the year 1996, what is the difference between the Value added (% of GDP) in Industry and Value added (% of GDP) in Services?
Your answer should be very brief. -23.18. In the year 1996, what is the difference between the Value added (% of GDP) of Industry and Value added (% of GDP) of Agriculture?
Provide a short and direct response. -24.28. In the year 1996, what is the difference between the Value added (% of GDP) in Manufacturing and Value added (% of GDP) in Services?
Your answer should be compact. -31.53. In the year 1996, what is the difference between the Value added (% of GDP) in Manufacturing and Value added (% of GDP) in Agriculture?
Keep it short and to the point. -32.63. In the year 1996, what is the difference between the Value added (% of GDP) of Services and Value added (% of GDP) of Agriculture?
Offer a very short reply. -1.1. In the year 1997, what is the difference between the Value added (% of GDP) of Industry and Value added (% of GDP) of Manufacturing?
Your answer should be compact. 8.06. In the year 1997, what is the difference between the Value added (% of GDP) of Industry and Value added (% of GDP) of Services?
Keep it short and to the point. -22.37. In the year 1997, what is the difference between the Value added (% of GDP) in Industry and Value added (% of GDP) in Agriculture?
Your answer should be very brief. -23.12. In the year 1997, what is the difference between the Value added (% of GDP) of Manufacturing and Value added (% of GDP) of Services?
Your response must be concise. -30.44. In the year 1997, what is the difference between the Value added (% of GDP) in Manufacturing and Value added (% of GDP) in Agriculture?
Your answer should be compact. -31.18. In the year 1997, what is the difference between the Value added (% of GDP) in Services and Value added (% of GDP) in Agriculture?
Provide a short and direct response. -0.75. In the year 1998, what is the difference between the Value added (% of GDP) of Industry and Value added (% of GDP) of Manufacturing?
Make the answer very short. 7.99. In the year 1998, what is the difference between the Value added (% of GDP) of Industry and Value added (% of GDP) of Services?
Offer a very short reply. -23.36. In the year 1998, what is the difference between the Value added (% of GDP) in Industry and Value added (% of GDP) in Agriculture?
Provide a short and direct response. -22.82. In the year 1998, what is the difference between the Value added (% of GDP) in Manufacturing and Value added (% of GDP) in Services?
Offer a very short reply. -31.35. In the year 1998, what is the difference between the Value added (% of GDP) in Manufacturing and Value added (% of GDP) in Agriculture?
Ensure brevity in your answer.  -30.81. In the year 1998, what is the difference between the Value added (% of GDP) in Services and Value added (% of GDP) in Agriculture?
Your response must be concise. 0.54. In the year 1999, what is the difference between the Value added (% of GDP) of Industry and Value added (% of GDP) of Manufacturing?
Offer a very short reply. 8.95. In the year 1999, what is the difference between the Value added (% of GDP) of Industry and Value added (% of GDP) of Services?
Your response must be concise. -23.05. In the year 1999, what is the difference between the Value added (% of GDP) in Industry and Value added (% of GDP) in Agriculture?
Your answer should be compact. -21.08. In the year 1999, what is the difference between the Value added (% of GDP) of Manufacturing and Value added (% of GDP) of Services?
Keep it short and to the point. -32. In the year 1999, what is the difference between the Value added (% of GDP) of Manufacturing and Value added (% of GDP) of Agriculture?
Your answer should be very brief. -30.04. In the year 1999, what is the difference between the Value added (% of GDP) of Services and Value added (% of GDP) of Agriculture?
Offer a terse response. 1.97. In the year 2000, what is the difference between the Value added (% of GDP) of Industry and Value added (% of GDP) of Manufacturing?
Your answer should be compact. 8.65. In the year 2000, what is the difference between the Value added (% of GDP) in Industry and Value added (% of GDP) in Services?
Give a very brief answer. -24.54. In the year 2000, what is the difference between the Value added (% of GDP) in Industry and Value added (% of GDP) in Agriculture?
Ensure brevity in your answer.  -21.57. In the year 2000, what is the difference between the Value added (% of GDP) of Manufacturing and Value added (% of GDP) of Services?
Offer a very short reply. -33.19. In the year 2000, what is the difference between the Value added (% of GDP) of Manufacturing and Value added (% of GDP) of Agriculture?
Provide a short and direct response. -30.22. In the year 2000, what is the difference between the Value added (% of GDP) in Services and Value added (% of GDP) in Agriculture?
Provide a succinct answer. 2.97. In the year 2001, what is the difference between the Value added (% of GDP) of Industry and Value added (% of GDP) of Manufacturing?
Keep it short and to the point. 8.7. In the year 2001, what is the difference between the Value added (% of GDP) in Industry and Value added (% of GDP) in Services?
Provide a succinct answer. -24.66. In the year 2001, what is the difference between the Value added (% of GDP) in Industry and Value added (% of GDP) in Agriculture?
Your response must be concise. -19.28. In the year 2001, what is the difference between the Value added (% of GDP) of Manufacturing and Value added (% of GDP) of Services?
Provide a succinct answer. -33.36. In the year 2001, what is the difference between the Value added (% of GDP) in Manufacturing and Value added (% of GDP) in Agriculture?
Ensure brevity in your answer.  -27.98. In the year 2001, what is the difference between the Value added (% of GDP) in Services and Value added (% of GDP) in Agriculture?
Your answer should be compact. 5.38. In the year 2002, what is the difference between the Value added (% of GDP) in Industry and Value added (% of GDP) in Manufacturing?
Keep it short and to the point. 9.48. In the year 2002, what is the difference between the Value added (% of GDP) of Industry and Value added (% of GDP) of Services?
Offer a very short reply. -23.98. In the year 2002, what is the difference between the Value added (% of GDP) in Industry and Value added (% of GDP) in Agriculture?
Your answer should be very brief. -16.78. In the year 2002, what is the difference between the Value added (% of GDP) in Manufacturing and Value added (% of GDP) in Services?
Ensure brevity in your answer.  -33.46. In the year 2002, what is the difference between the Value added (% of GDP) of Manufacturing and Value added (% of GDP) of Agriculture?
Ensure brevity in your answer.  -26.26. In the year 2002, what is the difference between the Value added (% of GDP) of Services and Value added (% of GDP) of Agriculture?
Keep it short and to the point. 7.2. What is the ratio of the Value added (% of GDP) of Industry in 1995 to that in 1996?
Ensure brevity in your answer.  0.94. What is the ratio of the Value added (% of GDP) of Manufacturing in 1995 to that in 1996?
Make the answer very short. 0.97. What is the ratio of the Value added (% of GDP) in Services in 1995 to that in 1996?
Offer a terse response. 1.01. What is the ratio of the Value added (% of GDP) of Agriculture in 1995 to that in 1996?
Make the answer very short. 0.98. What is the ratio of the Value added (% of GDP) of Industry in 1995 to that in 1997?
Your answer should be compact. 0.94. What is the ratio of the Value added (% of GDP) of Manufacturing in 1995 to that in 1997?
Provide a short and direct response. 0.94. What is the ratio of the Value added (% of GDP) in Services in 1995 to that in 1997?
Ensure brevity in your answer.  1.03. What is the ratio of the Value added (% of GDP) in Agriculture in 1995 to that in 1997?
Give a very brief answer. 1.01. What is the ratio of the Value added (% of GDP) of Industry in 1995 to that in 1998?
Ensure brevity in your answer.  0.91. What is the ratio of the Value added (% of GDP) in Manufacturing in 1995 to that in 1998?
Your answer should be very brief. 0.88. What is the ratio of the Value added (% of GDP) of Industry in 1995 to that in 1999?
Offer a very short reply. 0.86. What is the ratio of the Value added (% of GDP) in Manufacturing in 1995 to that in 1999?
Your answer should be compact. 0.88. What is the ratio of the Value added (% of GDP) in Services in 1995 to that in 1999?
Your response must be concise. 0.98. What is the ratio of the Value added (% of GDP) of Agriculture in 1995 to that in 1999?
Your answer should be very brief. 1.02. What is the ratio of the Value added (% of GDP) in Industry in 1995 to that in 2000?
Offer a terse response. 0.85. What is the ratio of the Value added (% of GDP) in Manufacturing in 1995 to that in 2000?
Keep it short and to the point. 0.83. What is the ratio of the Value added (% of GDP) of Services in 1995 to that in 2000?
Your answer should be very brief. 0.94. What is the ratio of the Value added (% of GDP) of Agriculture in 1995 to that in 2000?
Offer a very short reply. 1. What is the ratio of the Value added (% of GDP) in Industry in 1995 to that in 2001?
Provide a short and direct response. 0.84. What is the ratio of the Value added (% of GDP) of Manufacturing in 1995 to that in 2001?
Provide a short and direct response. 0.82. What is the ratio of the Value added (% of GDP) of Services in 1995 to that in 2001?
Your response must be concise. 0.93. What is the ratio of the Value added (% of GDP) of Industry in 1995 to that in 2002?
Your answer should be very brief. 0.81. What is the ratio of the Value added (% of GDP) of Manufacturing in 1995 to that in 2002?
Provide a short and direct response. 0.82. What is the ratio of the Value added (% of GDP) in Services in 1995 to that in 2002?
Provide a short and direct response. 0.93. What is the ratio of the Value added (% of GDP) in Agriculture in 1995 to that in 2002?
Provide a succinct answer. 1.1. What is the ratio of the Value added (% of GDP) in Manufacturing in 1996 to that in 1997?
Keep it short and to the point. 0.97. What is the ratio of the Value added (% of GDP) of Services in 1996 to that in 1997?
Your response must be concise. 1.02. What is the ratio of the Value added (% of GDP) of Agriculture in 1996 to that in 1997?
Keep it short and to the point. 1.03. What is the ratio of the Value added (% of GDP) of Industry in 1996 to that in 1998?
Give a very brief answer. 0.97. What is the ratio of the Value added (% of GDP) in Manufacturing in 1996 to that in 1998?
Provide a short and direct response. 0.92. What is the ratio of the Value added (% of GDP) of Services in 1996 to that in 1998?
Offer a terse response. 0.98. What is the ratio of the Value added (% of GDP) in Agriculture in 1996 to that in 1998?
Offer a very short reply. 1.02. What is the ratio of the Value added (% of GDP) in Industry in 1996 to that in 1999?
Your answer should be very brief. 0.92. What is the ratio of the Value added (% of GDP) of Agriculture in 1996 to that in 1999?
Your answer should be very brief. 1.04. What is the ratio of the Value added (% of GDP) of Industry in 1996 to that in 2000?
Keep it short and to the point. 0.9. What is the ratio of the Value added (% of GDP) in Manufacturing in 1996 to that in 2000?
Your response must be concise. 0.86. What is the ratio of the Value added (% of GDP) in Services in 1996 to that in 2000?
Offer a terse response. 0.93. What is the ratio of the Value added (% of GDP) of Agriculture in 1996 to that in 2000?
Ensure brevity in your answer.  1.02. What is the ratio of the Value added (% of GDP) of Industry in 1996 to that in 2001?
Provide a succinct answer. 0.9. What is the ratio of the Value added (% of GDP) in Manufacturing in 1996 to that in 2001?
Make the answer very short. 0.85. What is the ratio of the Value added (% of GDP) in Services in 1996 to that in 2001?
Provide a succinct answer. 0.92. What is the ratio of the Value added (% of GDP) in Agriculture in 1996 to that in 2001?
Your answer should be very brief. 1.07. What is the ratio of the Value added (% of GDP) of Industry in 1996 to that in 2002?
Provide a short and direct response. 0.86. What is the ratio of the Value added (% of GDP) in Manufacturing in 1996 to that in 2002?
Keep it short and to the point. 0.85. What is the ratio of the Value added (% of GDP) in Services in 1996 to that in 2002?
Your response must be concise. 0.92. What is the ratio of the Value added (% of GDP) in Agriculture in 1996 to that in 2002?
Your response must be concise. 1.12. What is the ratio of the Value added (% of GDP) in Industry in 1997 to that in 1998?
Ensure brevity in your answer.  0.97. What is the ratio of the Value added (% of GDP) in Manufacturing in 1997 to that in 1998?
Provide a succinct answer. 0.94. What is the ratio of the Value added (% of GDP) in Agriculture in 1997 to that in 1998?
Offer a terse response. 0.99. What is the ratio of the Value added (% of GDP) of Industry in 1997 to that in 1999?
Your response must be concise. 0.92. What is the ratio of the Value added (% of GDP) of Manufacturing in 1997 to that in 1999?
Provide a short and direct response. 0.94. What is the ratio of the Value added (% of GDP) in Services in 1997 to that in 1999?
Ensure brevity in your answer.  0.95. What is the ratio of the Value added (% of GDP) in Agriculture in 1997 to that in 1999?
Give a very brief answer. 1.01. What is the ratio of the Value added (% of GDP) in Industry in 1997 to that in 2000?
Offer a very short reply. 0.9. What is the ratio of the Value added (% of GDP) in Manufacturing in 1997 to that in 2000?
Provide a succinct answer. 0.88. What is the ratio of the Value added (% of GDP) of Services in 1997 to that in 2000?
Offer a terse response. 0.91. What is the ratio of the Value added (% of GDP) in Industry in 1997 to that in 2001?
Provide a short and direct response. 0.9. What is the ratio of the Value added (% of GDP) in Manufacturing in 1997 to that in 2001?
Your response must be concise. 0.87. What is the ratio of the Value added (% of GDP) of Services in 1997 to that in 2001?
Your answer should be very brief. 0.9. What is the ratio of the Value added (% of GDP) of Agriculture in 1997 to that in 2001?
Offer a very short reply. 1.04. What is the ratio of the Value added (% of GDP) of Industry in 1997 to that in 2002?
Your answer should be compact. 0.86. What is the ratio of the Value added (% of GDP) in Manufacturing in 1997 to that in 2002?
Your response must be concise. 0.87. What is the ratio of the Value added (% of GDP) in Services in 1997 to that in 2002?
Give a very brief answer. 0.9. What is the ratio of the Value added (% of GDP) of Agriculture in 1997 to that in 2002?
Offer a terse response. 1.09. What is the ratio of the Value added (% of GDP) in Industry in 1998 to that in 1999?
Ensure brevity in your answer.  0.95. What is the ratio of the Value added (% of GDP) in Manufacturing in 1998 to that in 1999?
Keep it short and to the point. 1. What is the ratio of the Value added (% of GDP) of Services in 1998 to that in 1999?
Your answer should be compact. 0.98. What is the ratio of the Value added (% of GDP) in Agriculture in 1998 to that in 1999?
Provide a succinct answer. 1.02. What is the ratio of the Value added (% of GDP) of Industry in 1998 to that in 2000?
Ensure brevity in your answer.  0.93. What is the ratio of the Value added (% of GDP) in Manufacturing in 1998 to that in 2000?
Your answer should be very brief. 0.94. What is the ratio of the Value added (% of GDP) of Services in 1998 to that in 2000?
Your response must be concise. 0.94. What is the ratio of the Value added (% of GDP) of Industry in 1998 to that in 2001?
Provide a succinct answer. 0.92. What is the ratio of the Value added (% of GDP) in Manufacturing in 1998 to that in 2001?
Offer a terse response. 0.93. What is the ratio of the Value added (% of GDP) of Services in 1998 to that in 2001?
Your response must be concise. 0.94. What is the ratio of the Value added (% of GDP) of Agriculture in 1998 to that in 2001?
Your answer should be compact. 1.05. What is the ratio of the Value added (% of GDP) in Industry in 1998 to that in 2002?
Ensure brevity in your answer.  0.89. What is the ratio of the Value added (% of GDP) of Manufacturing in 1998 to that in 2002?
Provide a succinct answer. 0.92. What is the ratio of the Value added (% of GDP) of Services in 1998 to that in 2002?
Offer a terse response. 0.93. What is the ratio of the Value added (% of GDP) in Agriculture in 1998 to that in 2002?
Your answer should be compact. 1.1. What is the ratio of the Value added (% of GDP) of Industry in 1999 to that in 2000?
Offer a very short reply. 0.98. What is the ratio of the Value added (% of GDP) in Manufacturing in 1999 to that in 2000?
Your answer should be very brief. 0.94. What is the ratio of the Value added (% of GDP) in Services in 1999 to that in 2000?
Provide a short and direct response. 0.96. What is the ratio of the Value added (% of GDP) in Agriculture in 1999 to that in 2000?
Your answer should be very brief. 0.98. What is the ratio of the Value added (% of GDP) in Industry in 1999 to that in 2001?
Make the answer very short. 0.97. What is the ratio of the Value added (% of GDP) of Manufacturing in 1999 to that in 2001?
Ensure brevity in your answer.  0.93. What is the ratio of the Value added (% of GDP) of Services in 1999 to that in 2001?
Offer a very short reply. 0.95. What is the ratio of the Value added (% of GDP) in Agriculture in 1999 to that in 2001?
Your response must be concise. 1.03. What is the ratio of the Value added (% of GDP) in Industry in 1999 to that in 2002?
Make the answer very short. 0.93. What is the ratio of the Value added (% of GDP) in Manufacturing in 1999 to that in 2002?
Offer a very short reply. 0.93. What is the ratio of the Value added (% of GDP) in Services in 1999 to that in 2002?
Provide a succinct answer. 0.95. What is the ratio of the Value added (% of GDP) of Agriculture in 1999 to that in 2002?
Your answer should be compact. 1.08. What is the ratio of the Value added (% of GDP) of Manufacturing in 2000 to that in 2001?
Keep it short and to the point. 0.99. What is the ratio of the Value added (% of GDP) in Agriculture in 2000 to that in 2001?
Your answer should be very brief. 1.05. What is the ratio of the Value added (% of GDP) in Industry in 2000 to that in 2002?
Make the answer very short. 0.95. What is the ratio of the Value added (% of GDP) of Manufacturing in 2000 to that in 2002?
Offer a terse response. 0.99. What is the ratio of the Value added (% of GDP) in Services in 2000 to that in 2002?
Offer a very short reply. 0.99. What is the ratio of the Value added (% of GDP) of Agriculture in 2000 to that in 2002?
Make the answer very short. 1.1. What is the ratio of the Value added (% of GDP) of Industry in 2001 to that in 2002?
Give a very brief answer. 0.96. What is the ratio of the Value added (% of GDP) of Manufacturing in 2001 to that in 2002?
Your answer should be compact. 1. What is the ratio of the Value added (% of GDP) of Services in 2001 to that in 2002?
Ensure brevity in your answer.  1. What is the ratio of the Value added (% of GDP) of Agriculture in 2001 to that in 2002?
Ensure brevity in your answer.  1.04. What is the difference between the highest and the second highest Value added (% of GDP) of Industry?
Your response must be concise. 0.83. What is the difference between the highest and the second highest Value added (% of GDP) in Manufacturing?
Your answer should be very brief. 0.05. What is the difference between the highest and the second highest Value added (% of GDP) of Services?
Your answer should be compact. 0.15. What is the difference between the highest and the second highest Value added (% of GDP) in Agriculture?
Keep it short and to the point. 0.81. What is the difference between the highest and the lowest Value added (% of GDP) in Industry?
Your answer should be very brief. 4.02. What is the difference between the highest and the lowest Value added (% of GDP) of Manufacturing?
Ensure brevity in your answer.  2.09. What is the difference between the highest and the lowest Value added (% of GDP) of Services?
Give a very brief answer. 4.53. What is the difference between the highest and the lowest Value added (% of GDP) in Agriculture?
Give a very brief answer. 4.6. 